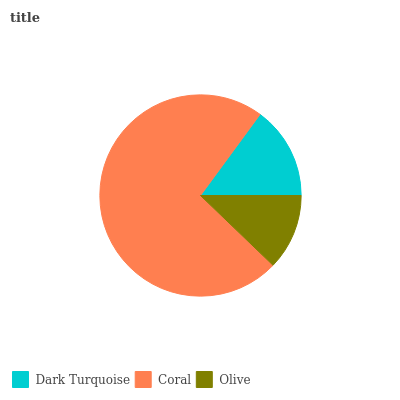Is Olive the minimum?
Answer yes or no. Yes. Is Coral the maximum?
Answer yes or no. Yes. Is Coral the minimum?
Answer yes or no. No. Is Olive the maximum?
Answer yes or no. No. Is Coral greater than Olive?
Answer yes or no. Yes. Is Olive less than Coral?
Answer yes or no. Yes. Is Olive greater than Coral?
Answer yes or no. No. Is Coral less than Olive?
Answer yes or no. No. Is Dark Turquoise the high median?
Answer yes or no. Yes. Is Dark Turquoise the low median?
Answer yes or no. Yes. Is Coral the high median?
Answer yes or no. No. Is Olive the low median?
Answer yes or no. No. 